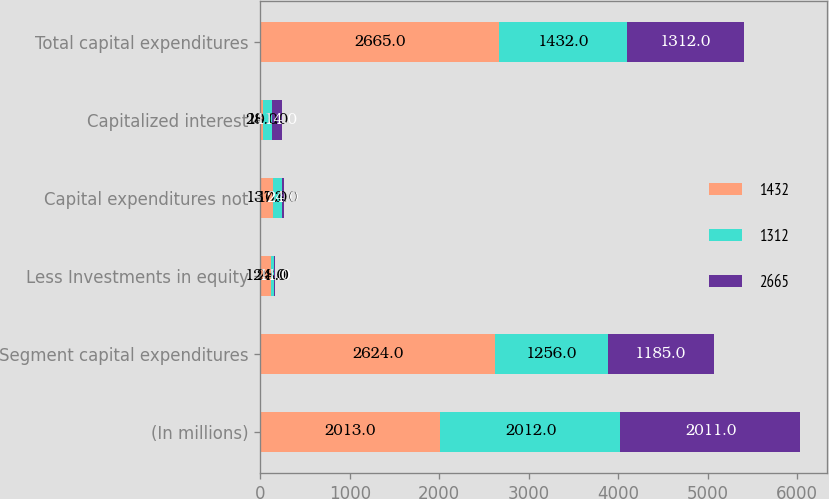<chart> <loc_0><loc_0><loc_500><loc_500><stacked_bar_chart><ecel><fcel>(In millions)<fcel>Segment capital expenditures<fcel>Less Investments in equity<fcel>Capital expenditures not<fcel>Capitalized interest<fcel>Total capital expenditures<nl><fcel>1432<fcel>2013<fcel>2624<fcel>124<fcel>137<fcel>28<fcel>2665<nl><fcel>1312<fcel>2012<fcel>1256<fcel>28<fcel>103<fcel>101<fcel>1432<nl><fcel>2665<fcel>2011<fcel>1185<fcel>11<fcel>24<fcel>114<fcel>1312<nl></chart> 